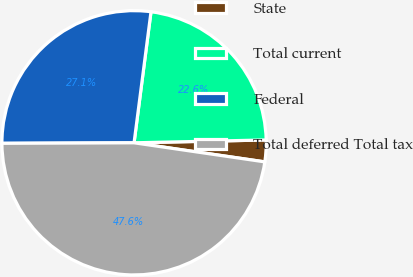<chart> <loc_0><loc_0><loc_500><loc_500><pie_chart><fcel>State<fcel>Total current<fcel>Federal<fcel>Total deferred Total tax<nl><fcel>2.65%<fcel>22.61%<fcel>27.11%<fcel>47.63%<nl></chart> 